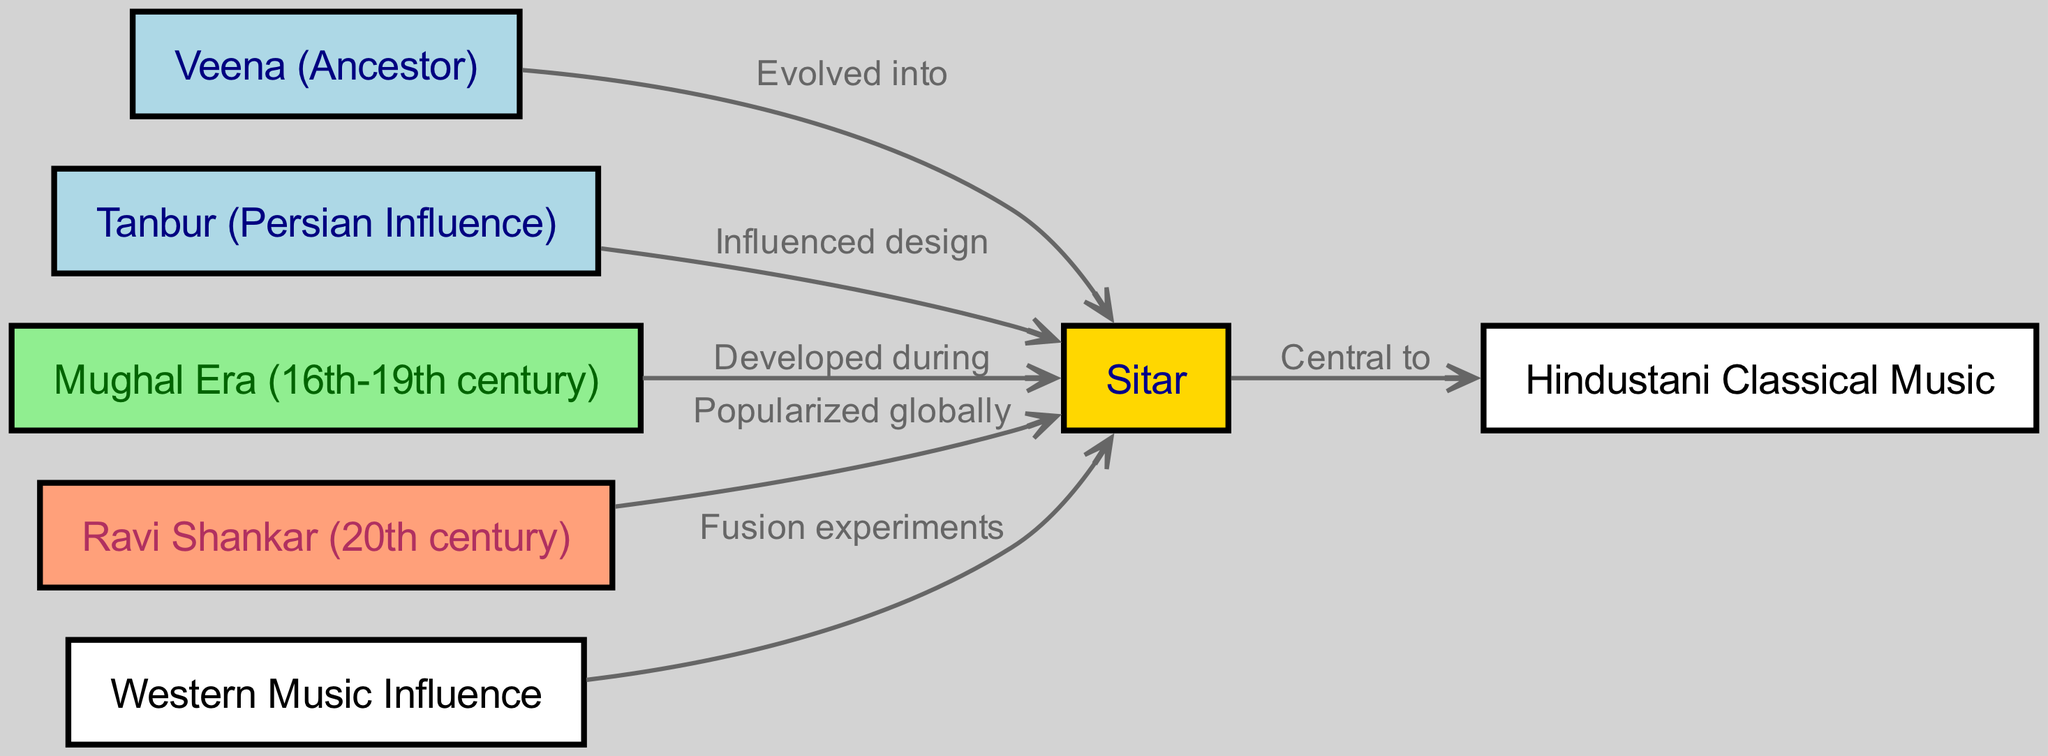What is the central node of this concept map? The diagram shows the sitar as the main focus, connecting various influences and historical elements surrounding its evolution. Directly from the edges and their connections to other nodes, it's clear that the sitar is the central node.
Answer: sitar How many nodes are present in the diagram? Count the distinct nodes listed in the diagram. The nodes include sitar, veena, tanbur, mughal, ravi shankar, hindustani, and western influence, totaling seven nodes.
Answer: 7 What instrument is shown as the ancestor of the sitar? The diagram specifically labels the veena as an ancestor, indicating it as the predecessor that contributed to the sitar's development.
Answer: Veena (Ancestor) Which historical influence developed the sitar during the 16th to 19th century? The diagram highlights the Mughal era as the time period when the sitar was developed, as indicated by a direct connection from the mughal node to the sitar.
Answer: Mughal Era (16th-19th century) Who popularized the sitar globally in the 20th century? The diagram includes the node for Ravi Shankar, which notes that he played a significant role in bringing the sitar to a worldwide audience, thus being the answer to the question.
Answer: Ravi Shankar (20th century) What influence is indicated as affecting the design of the sitar? According to the diagram, the tanbur is specifically noted to have influenced the design of the sitar, as depicted by the connection line and label showing this influence.
Answer: Tanbur (Persian Influence) How does the sitar relate to Hindustani classical music? The diagram provides a direct connection, indicating that the sitar is central to Hindustani classical music, showing its importance within that musical tradition.
Answer: Central to Hindustani Classical Music What is the relationship between western influence and the sitar? The diagram shows that western influence relates to the sitar through fusion experiments, indicating a collaborative or merging of musical styles.
Answer: Fusion experiments Which two instruments are connected to the sitar in the diagram? The two instruments connected to the sitar are the veena and the tanbur, with distinct labels explaining their roles in the sitar’s evolution.
Answer: Veena, Tanbur What time period does the Mughal era represent in relation to the sitar? The diagram specifies the Mughal era as representing the time interval from the 16th to the 19th century, connecting the historical background to the development of the sitar.
Answer: 16th-19th century 